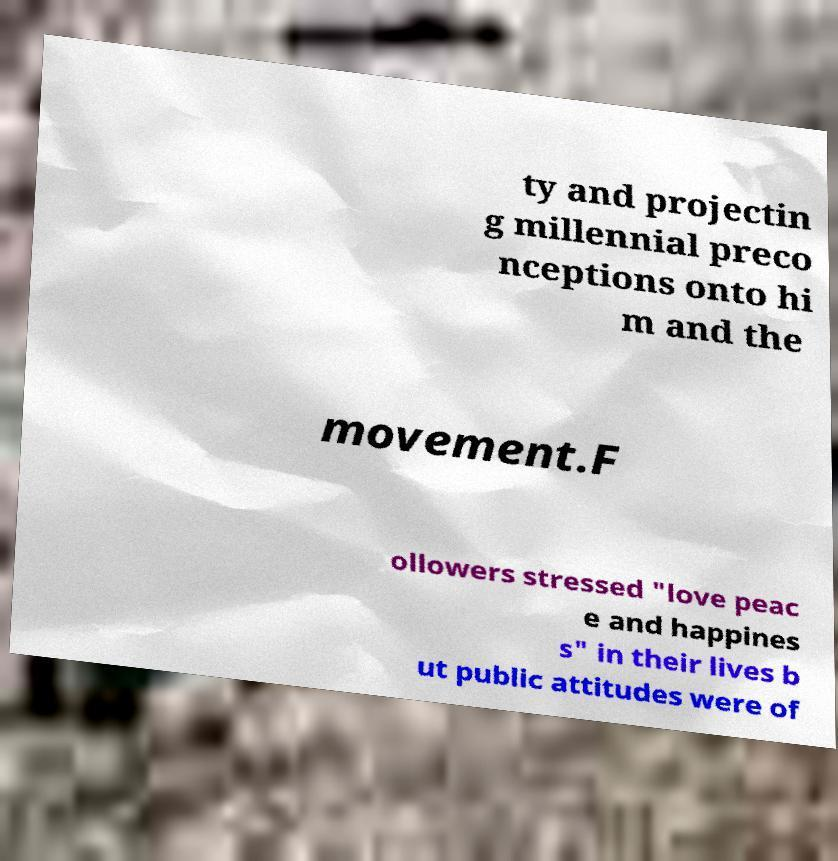Could you extract and type out the text from this image? ty and projectin g millennial preco nceptions onto hi m and the movement.F ollowers stressed "love peac e and happines s" in their lives b ut public attitudes were of 